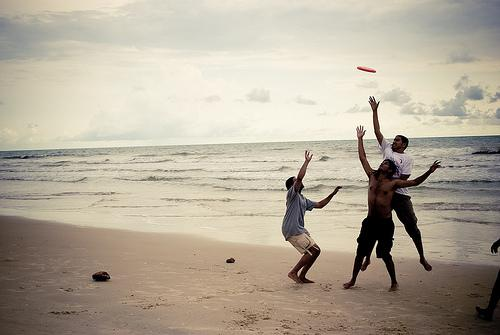What color is the shirt of the person closest to the frisbee? The shirt is white. Describe the weather and sky condition in the image. The sky is filled with white fluffy clouds, giving a grayish appearance. Select a question suitable for a multi-choice VQA task, provide the question and four possible answers. Options: a) Black b) Brown c) Blue d) White Which person in the image is jumping? A man jumping up in the air. Describe any distinctive pattern observed in the sand in the image. There are tracks in the brown sand on the beach. Identify the main activity that the people in the image are participating in. A group of young boys are playing frisbee at the beach. Create a referential expression for the product placement of a new beverage in the beach scene. "Enjoy a cool and refreshing [Beverage Brand] while playing frisbee with friends on a beach with calm ocean waves and soft brown sand under a sky filled with fluffy clouds." Imagine this as a fitness advertisement. Write a line to describe the image in relation to fitness in natural language. "Get active and stay fit with friends, enjoy a game of frisbee on the beach while soaking up the sun and creating memories!" Pick a person in the image and describe what he is wearing. One man is wearing a grey shirt and tan pants. What object is flying in the air in the image? An orange frisbee. 